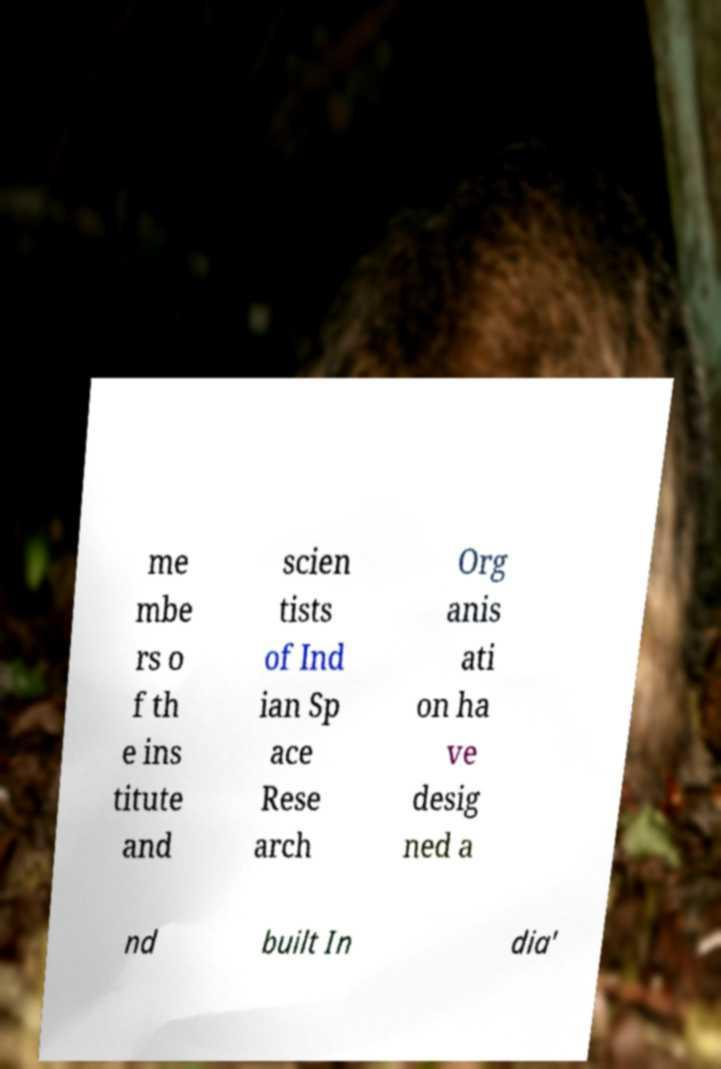Can you accurately transcribe the text from the provided image for me? me mbe rs o f th e ins titute and scien tists of Ind ian Sp ace Rese arch Org anis ati on ha ve desig ned a nd built In dia' 